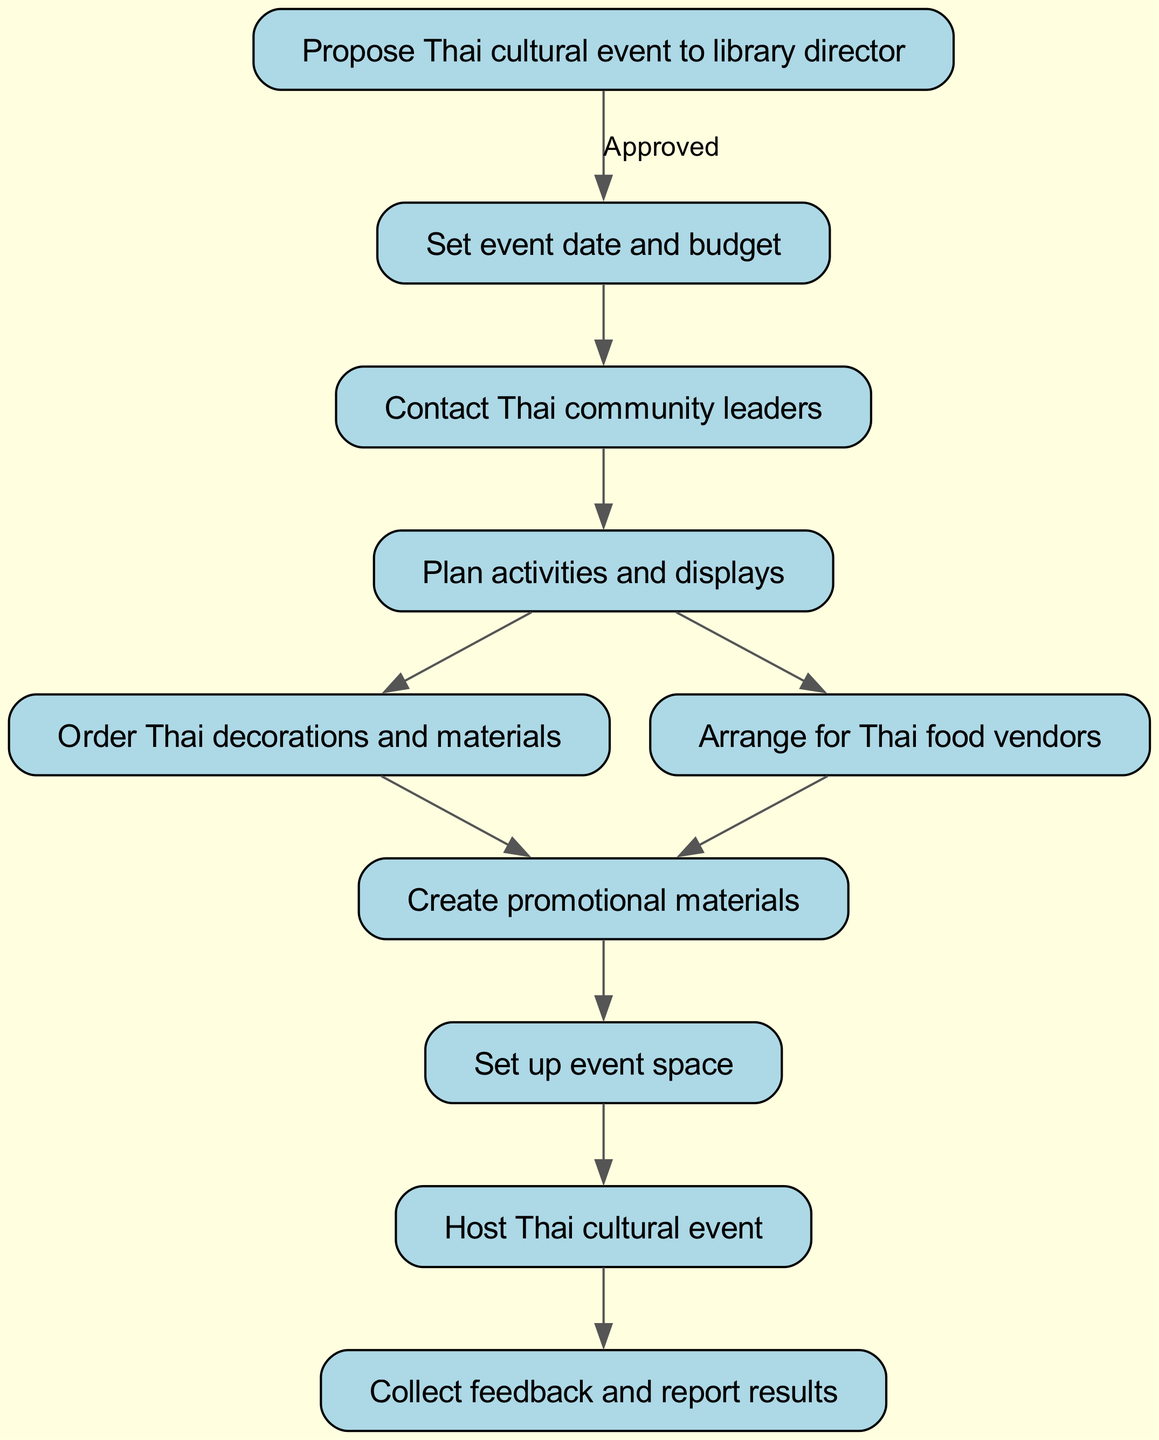What is the first step in the workflow? The first step in the workflow is to propose the Thai cultural event to the library director. This is the starting point of the flowchart and is represented by the first node.
Answer: Propose Thai cultural event to library director How many nodes are there in the diagram? The diagram contains 10 nodes, which represent the different steps in organizing the Thai cultural event, including planning, execution, and feedback collection.
Answer: 10 What activity is planned after contacting Thai community leaders? After contacting Thai community leaders, the next activity planned is to plan activities and displays. This is shown by the edge leading from the third node to the fourth.
Answer: Plan activities and displays What is the relationship between planning activities and ordering decorations? The relationship is that planning activities must occur before ordering decorations. The flow progresses from the fourth node (plan activities) to the fifth node (order Thai decorations), indicating a sequential dependency.
Answer: Sequential dependency How many edges connect the nodes in the workflow? There are 9 edges connecting the nodes, which indicate the flow and relationships between the various steps in organizing the event. Each edge represents a connection from one step to another.
Answer: 9 What happens just before hosting the Thai cultural event? Just before hosting the Thai cultural event, the event space is set up. This follows the node that indicates the setup of the event space, leading directly to hosting the event.
Answer: Set up event space What are the last two steps in the workflow? The last two steps in the workflow are hosting the Thai cultural event and collecting feedback and reporting results. These steps conclude the event organization process, with the final node capturing the outcome.
Answer: Host Thai cultural event, Collect feedback and report results What is the significance of the edge labeled "Approved"? The edge labeled "Approved" signifies that the proposal for the Thai cultural event must be approved by the library director before proceeding to set the event date and budget. This indicates a decision point in the workflow.
Answer: Decision point 